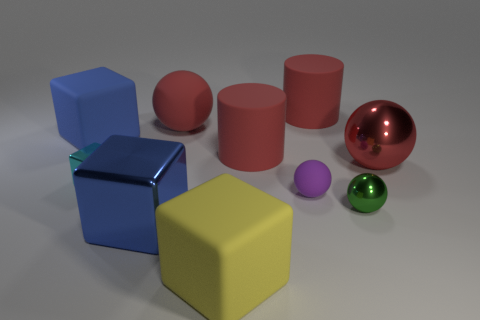What makes the red object different from the others? The red object stands out because it has a reflective, glossy surface, in contrast to the matte finish of the other objects. Additionally, it is the only sphere among several cubic and cylindrical shapes. 